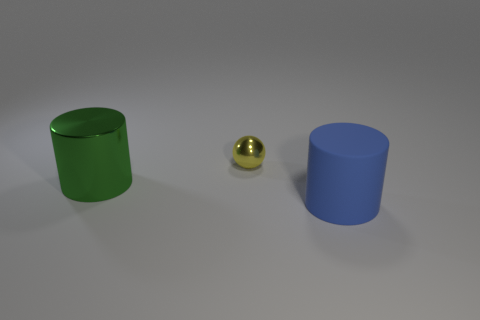Add 3 blue matte things. How many objects exist? 6 Subtract all cylinders. How many objects are left? 1 Subtract all tiny yellow spheres. Subtract all big green metal cylinders. How many objects are left? 1 Add 2 big things. How many big things are left? 4 Add 1 tiny green cylinders. How many tiny green cylinders exist? 1 Subtract 1 yellow spheres. How many objects are left? 2 